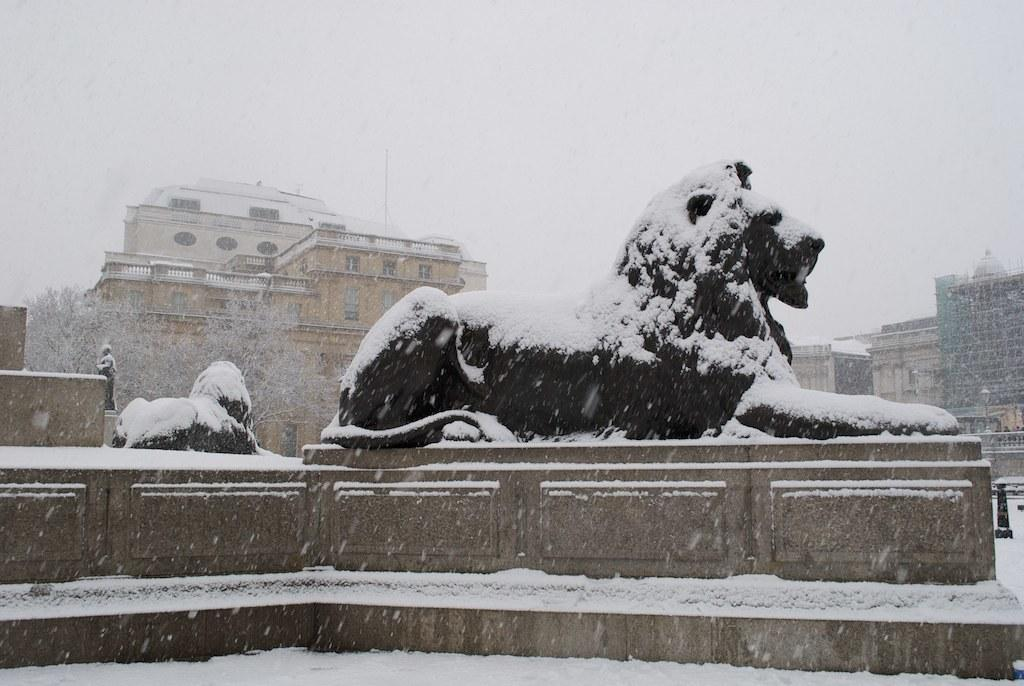What can be seen on stands in the image? There are statues on stands in the image. What is covering the statues? There is snow on the statues. What other objects are present in the image? There are poles, trees, and buildings in the image. What is visible in the sky in the image? The sky is visible in the image and appears cloudy. What type of liquid can be heard splashing in the image? There is no liquid present in the image, nor is there any sound mentioned or depicted. 